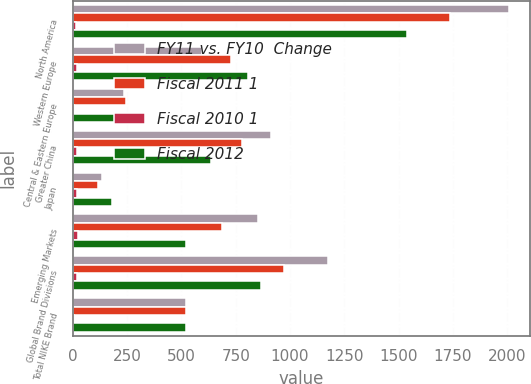Convert chart. <chart><loc_0><loc_0><loc_500><loc_500><stacked_bar_chart><ecel><fcel>North America<fcel>Western Europe<fcel>Central & Eastern Europe<fcel>Greater China<fcel>Japan<fcel>Emerging Markets<fcel>Global Brand Divisions<fcel>Total NIKE Brand<nl><fcel>FY11 vs. FY10  Change<fcel>2007<fcel>597<fcel>234<fcel>911<fcel>136<fcel>853<fcel>1177<fcel>521<nl><fcel>Fiscal 2011 1<fcel>1736<fcel>730<fcel>244<fcel>777<fcel>114<fcel>688<fcel>971<fcel>521<nl><fcel>Fiscal 2010 1<fcel>16<fcel>18<fcel>4<fcel>17<fcel>19<fcel>24<fcel>21<fcel>7<nl><fcel>Fiscal 2012<fcel>1538<fcel>807<fcel>249<fcel>637<fcel>180<fcel>521<fcel>866<fcel>521<nl></chart> 